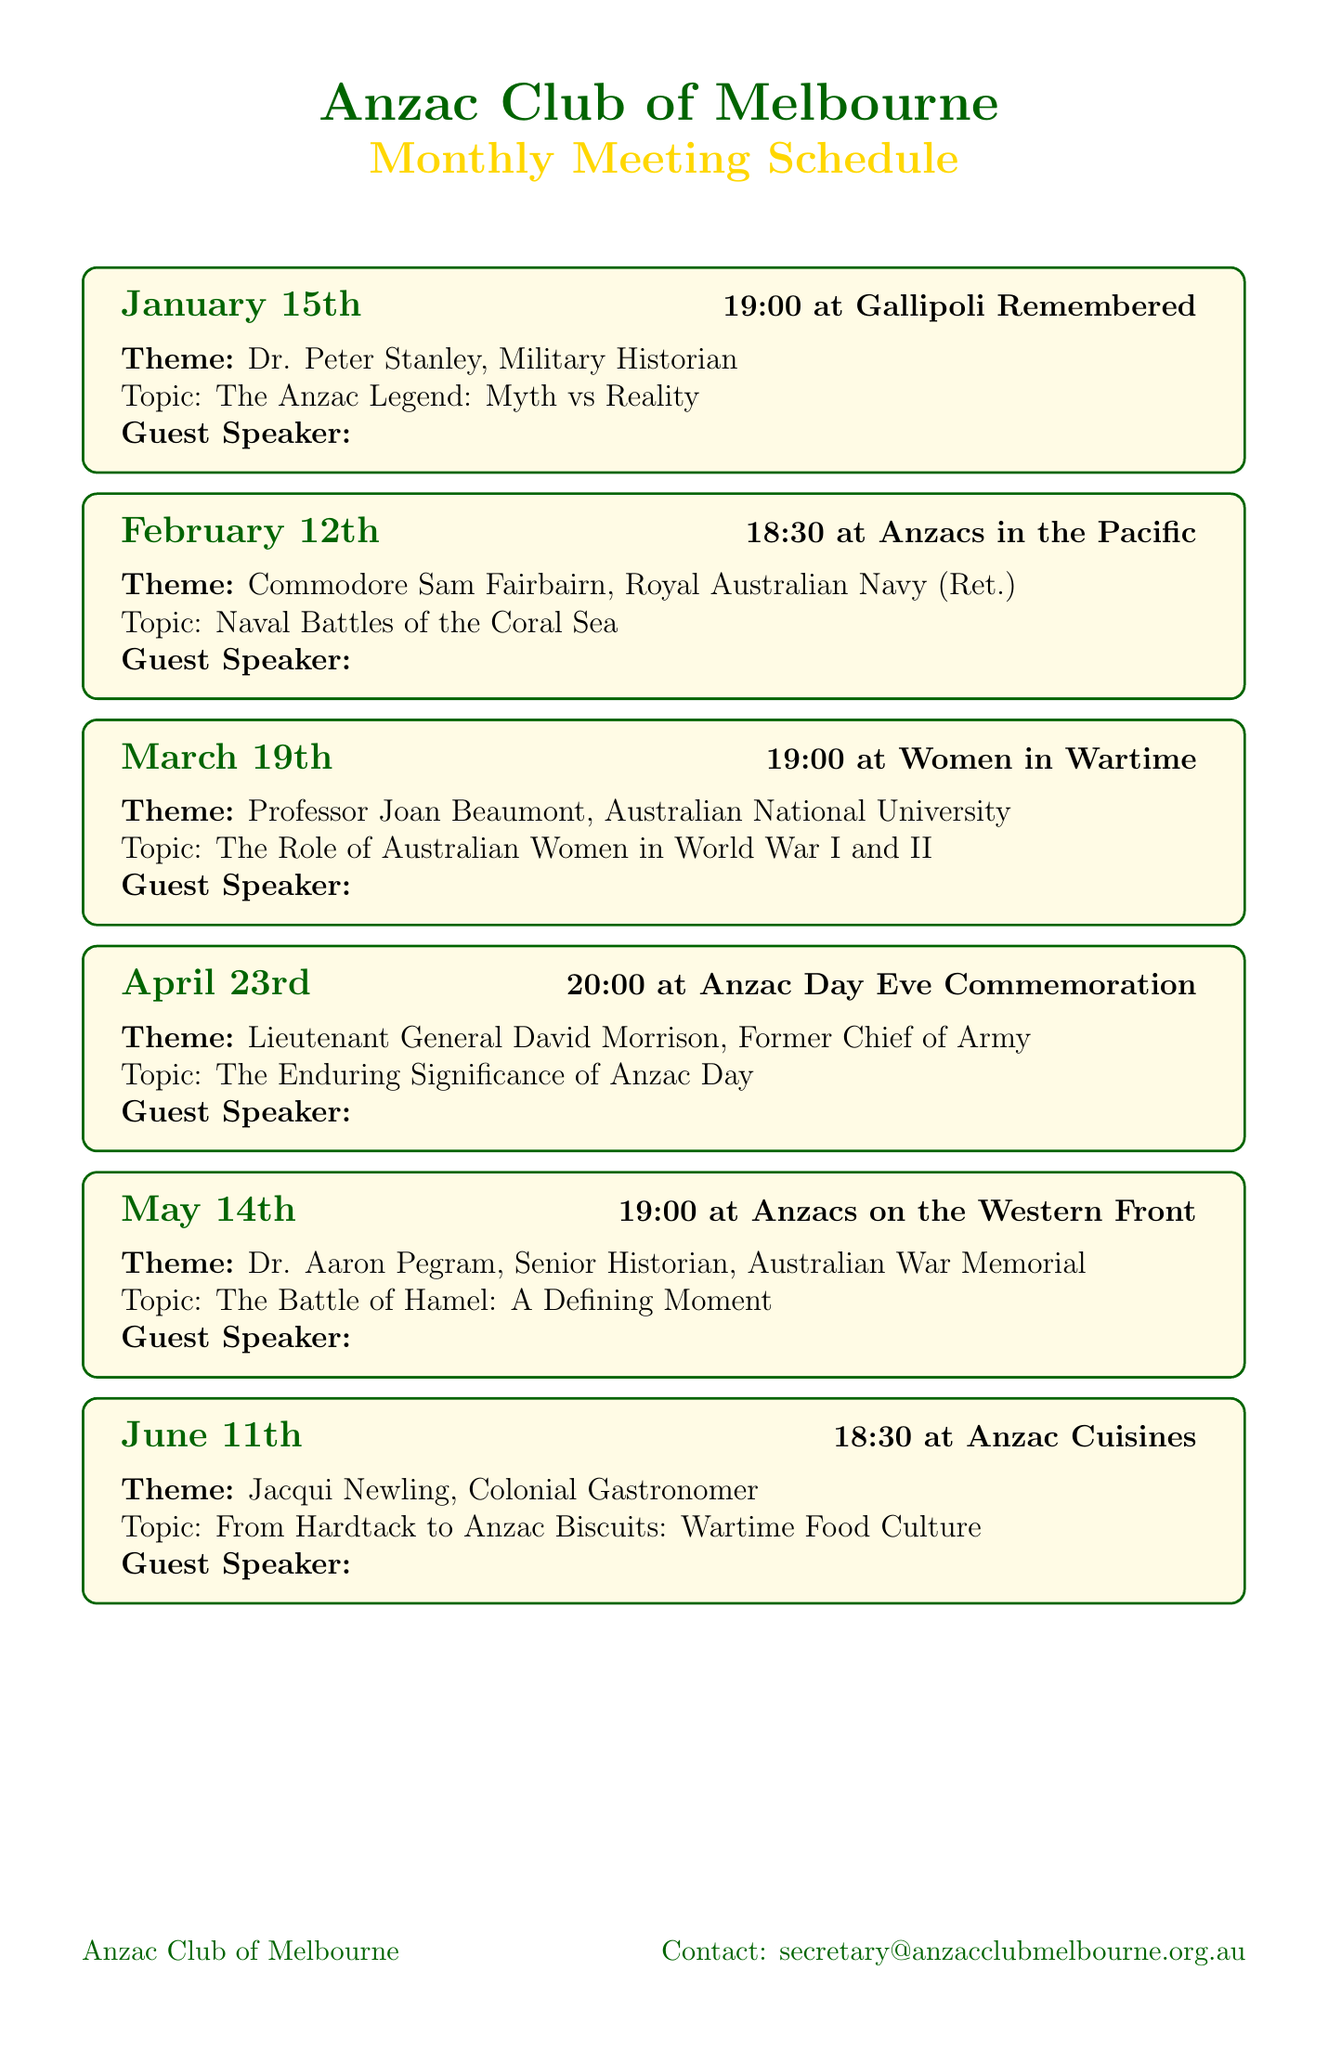what is the theme for the January meeting? The theme for the January meeting is stated directly in the schedule under the January entry.
Answer: Gallipoli Remembered who is the guest speaker in February? The guest speaker for February is mentioned under the February entry in the document.
Answer: Commodore Sam Fairbairn what time does the March meeting start? The time for the March meeting is specified in the March entry within the schedule.
Answer: 19:00 how many meetings are scheduled before Anzac Day? To find this, count the number of meetings listed before April 23rd, which is Anzac Day Eve.
Answer: Three what is the additional activity planned for the June meeting? The additional activity for June is mentioned directly under the June entry in the document.
Answer: Tasting session of traditional Anzac recipes what is the venue for the meetings? The venue is stated explicitly at the end of the document.
Answer: Anzac House, 4 Collins Street, Melbourne who is the speaker discussing the role of women in wartime? The speaker's name and title are provided in the March meeting entry.
Answer: Professor Joan Beaumont what is the annual membership fee? The membership fee is listed distinctly in the document under the membership requirements section.
Answer: AUD 50 what documentary will be screened in February? The documentary title is mentioned in the February meeting's additional activities.
Answer: Kokoda: The Spirit Lives 